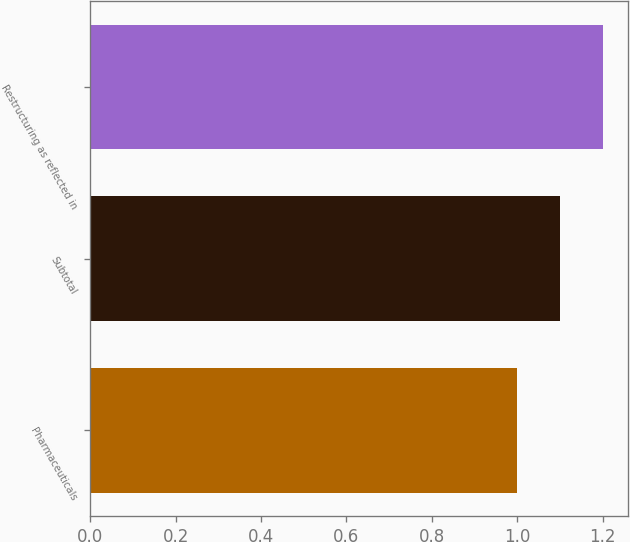Convert chart to OTSL. <chart><loc_0><loc_0><loc_500><loc_500><bar_chart><fcel>Pharmaceuticals<fcel>Subtotal<fcel>Restructuring as reflected in<nl><fcel>1<fcel>1.1<fcel>1.2<nl></chart> 